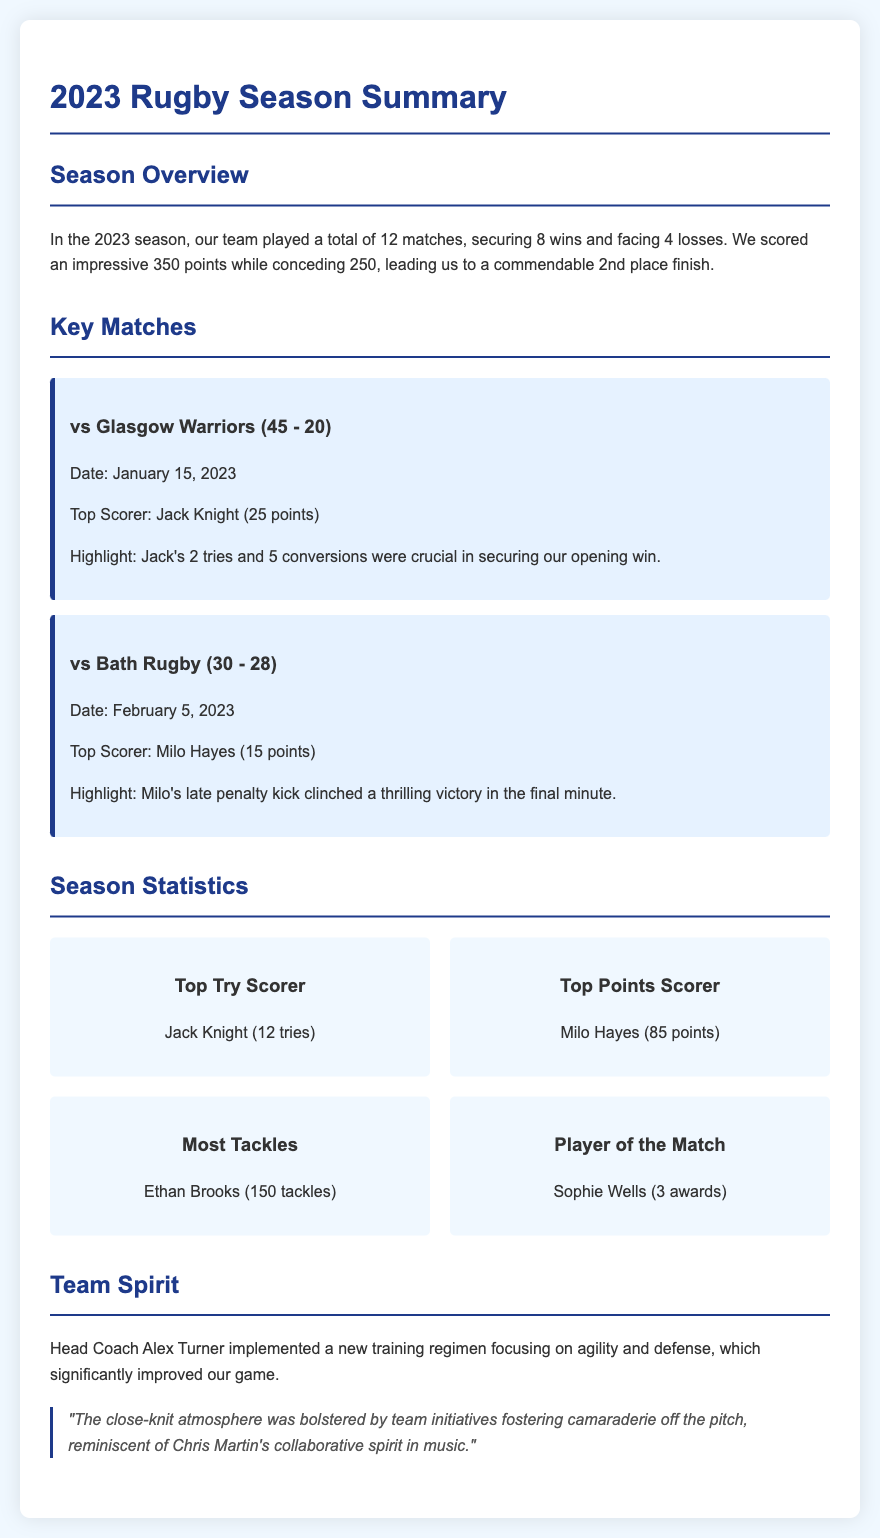what was the team's total number of matches played? The document states that the team played a total of 12 matches during the season.
Answer: 12 who was the top scorer in the match against Glasgow Warriors? According to the match details, Jack Knight scored 25 points in that match.
Answer: Jack Knight how many tries did Jack Knight score during the season? The statistics indicate that Jack Knight was the top try scorer with a total of 12 tries.
Answer: 12 tries what was the final score in the match against Bath Rugby? The document lists the final score against Bath Rugby as 30 - 28.
Answer: 30 - 28 how many points did Milo Hayes score in total during the season? Milo Hayes is noted as the top points scorer with a total of 85 points.
Answer: 85 points who received the most Player of the Match awards? The document states that Sophie Wells received 3 Player of the Match awards, making her the recipient of the most awards during the season.
Answer: Sophie Wells when did the team play against Glasgow Warriors? The match against Glasgow Warriors took place on January 15, 2023.
Answer: January 15, 2023 what training focus did Head Coach Alex Turner implement? The document mentions that the new training regimen focused on agility and defense.
Answer: Agility and defense 